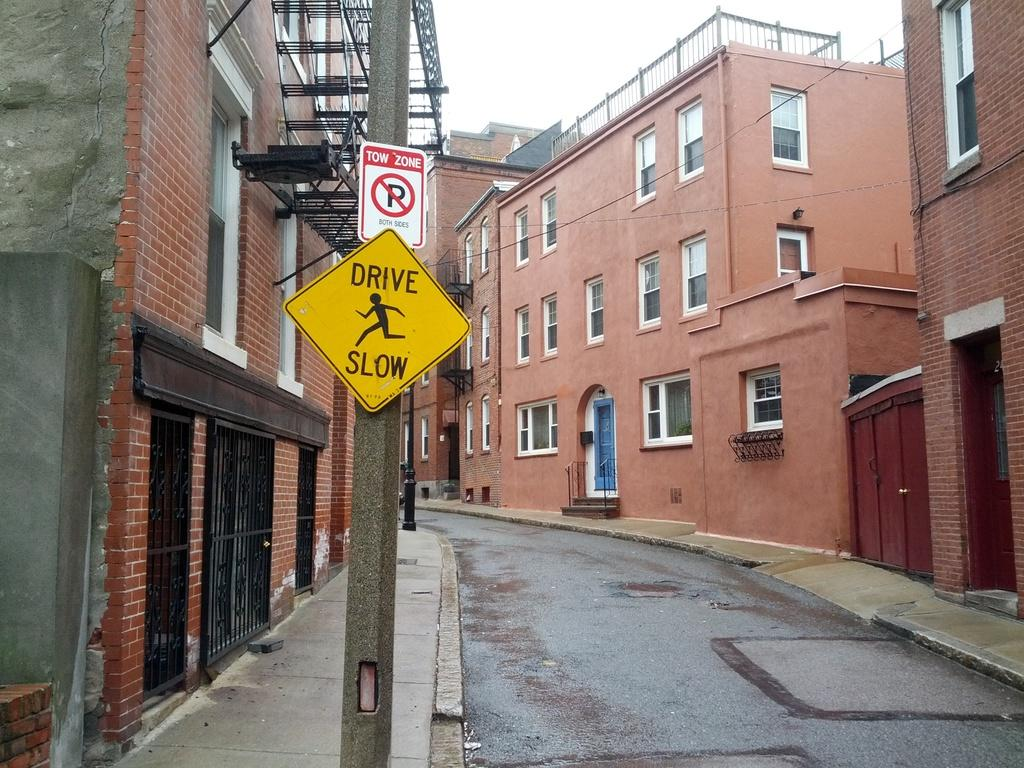What type of structures are present in the image? There are buildings in the image. What features can be seen on the buildings? The buildings have windows, doors, and gates. What other infrastructure elements are visible in the image? There are electric poles and a road in the image. Are there any other objects present in the image besides the buildings and infrastructure? Yes, there are other objects in the image. How does the crowd in the image react to the addition of a new building? There is no crowd present in the image, and no new building is being added. 